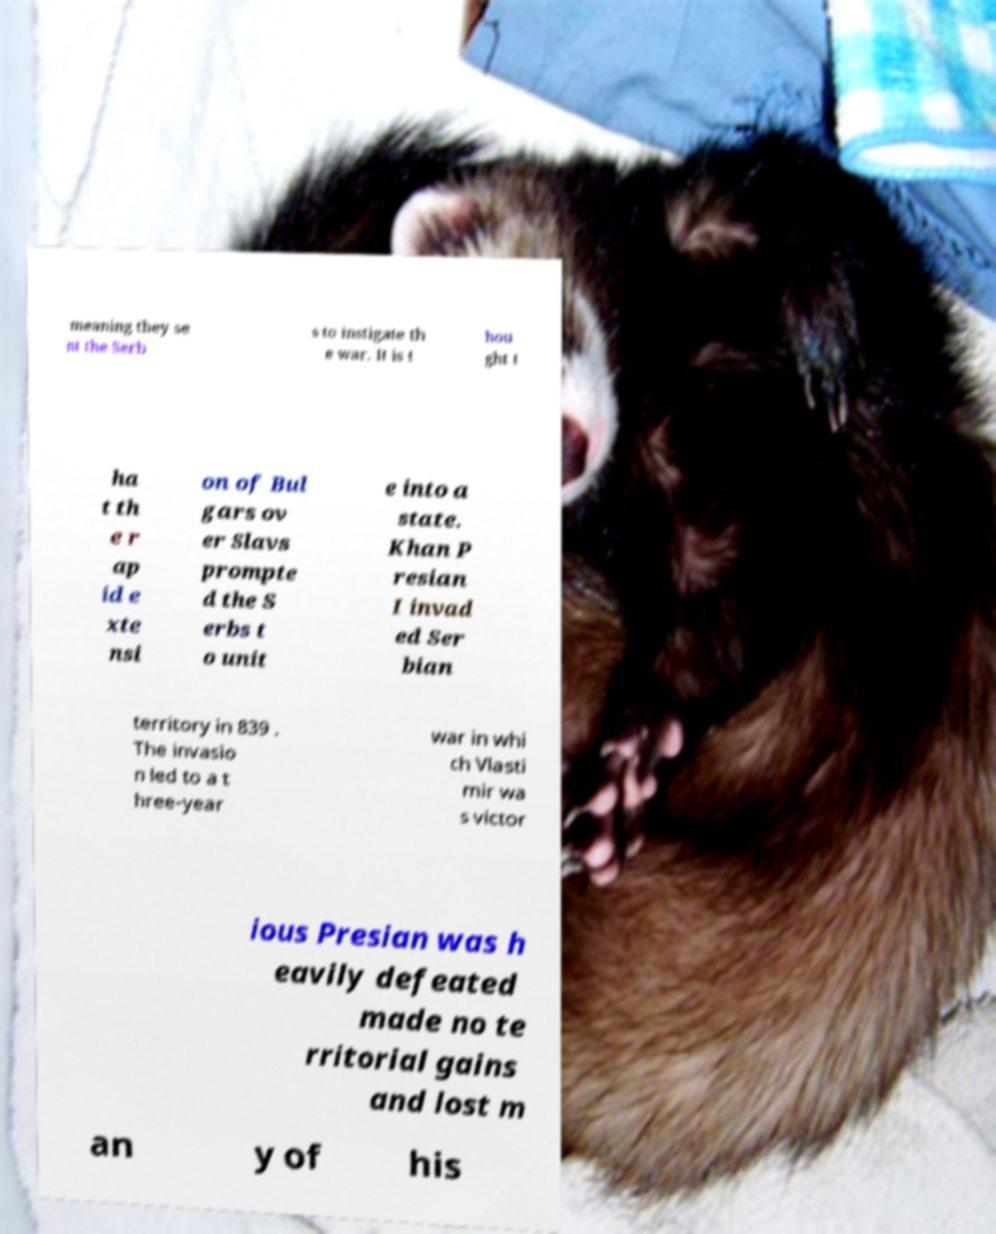For documentation purposes, I need the text within this image transcribed. Could you provide that? meaning they se nt the Serb s to instigate th e war. It is t hou ght t ha t th e r ap id e xte nsi on of Bul gars ov er Slavs prompte d the S erbs t o unit e into a state. Khan P resian I invad ed Ser bian territory in 839 . The invasio n led to a t hree-year war in whi ch Vlasti mir wa s victor ious Presian was h eavily defeated made no te rritorial gains and lost m an y of his 